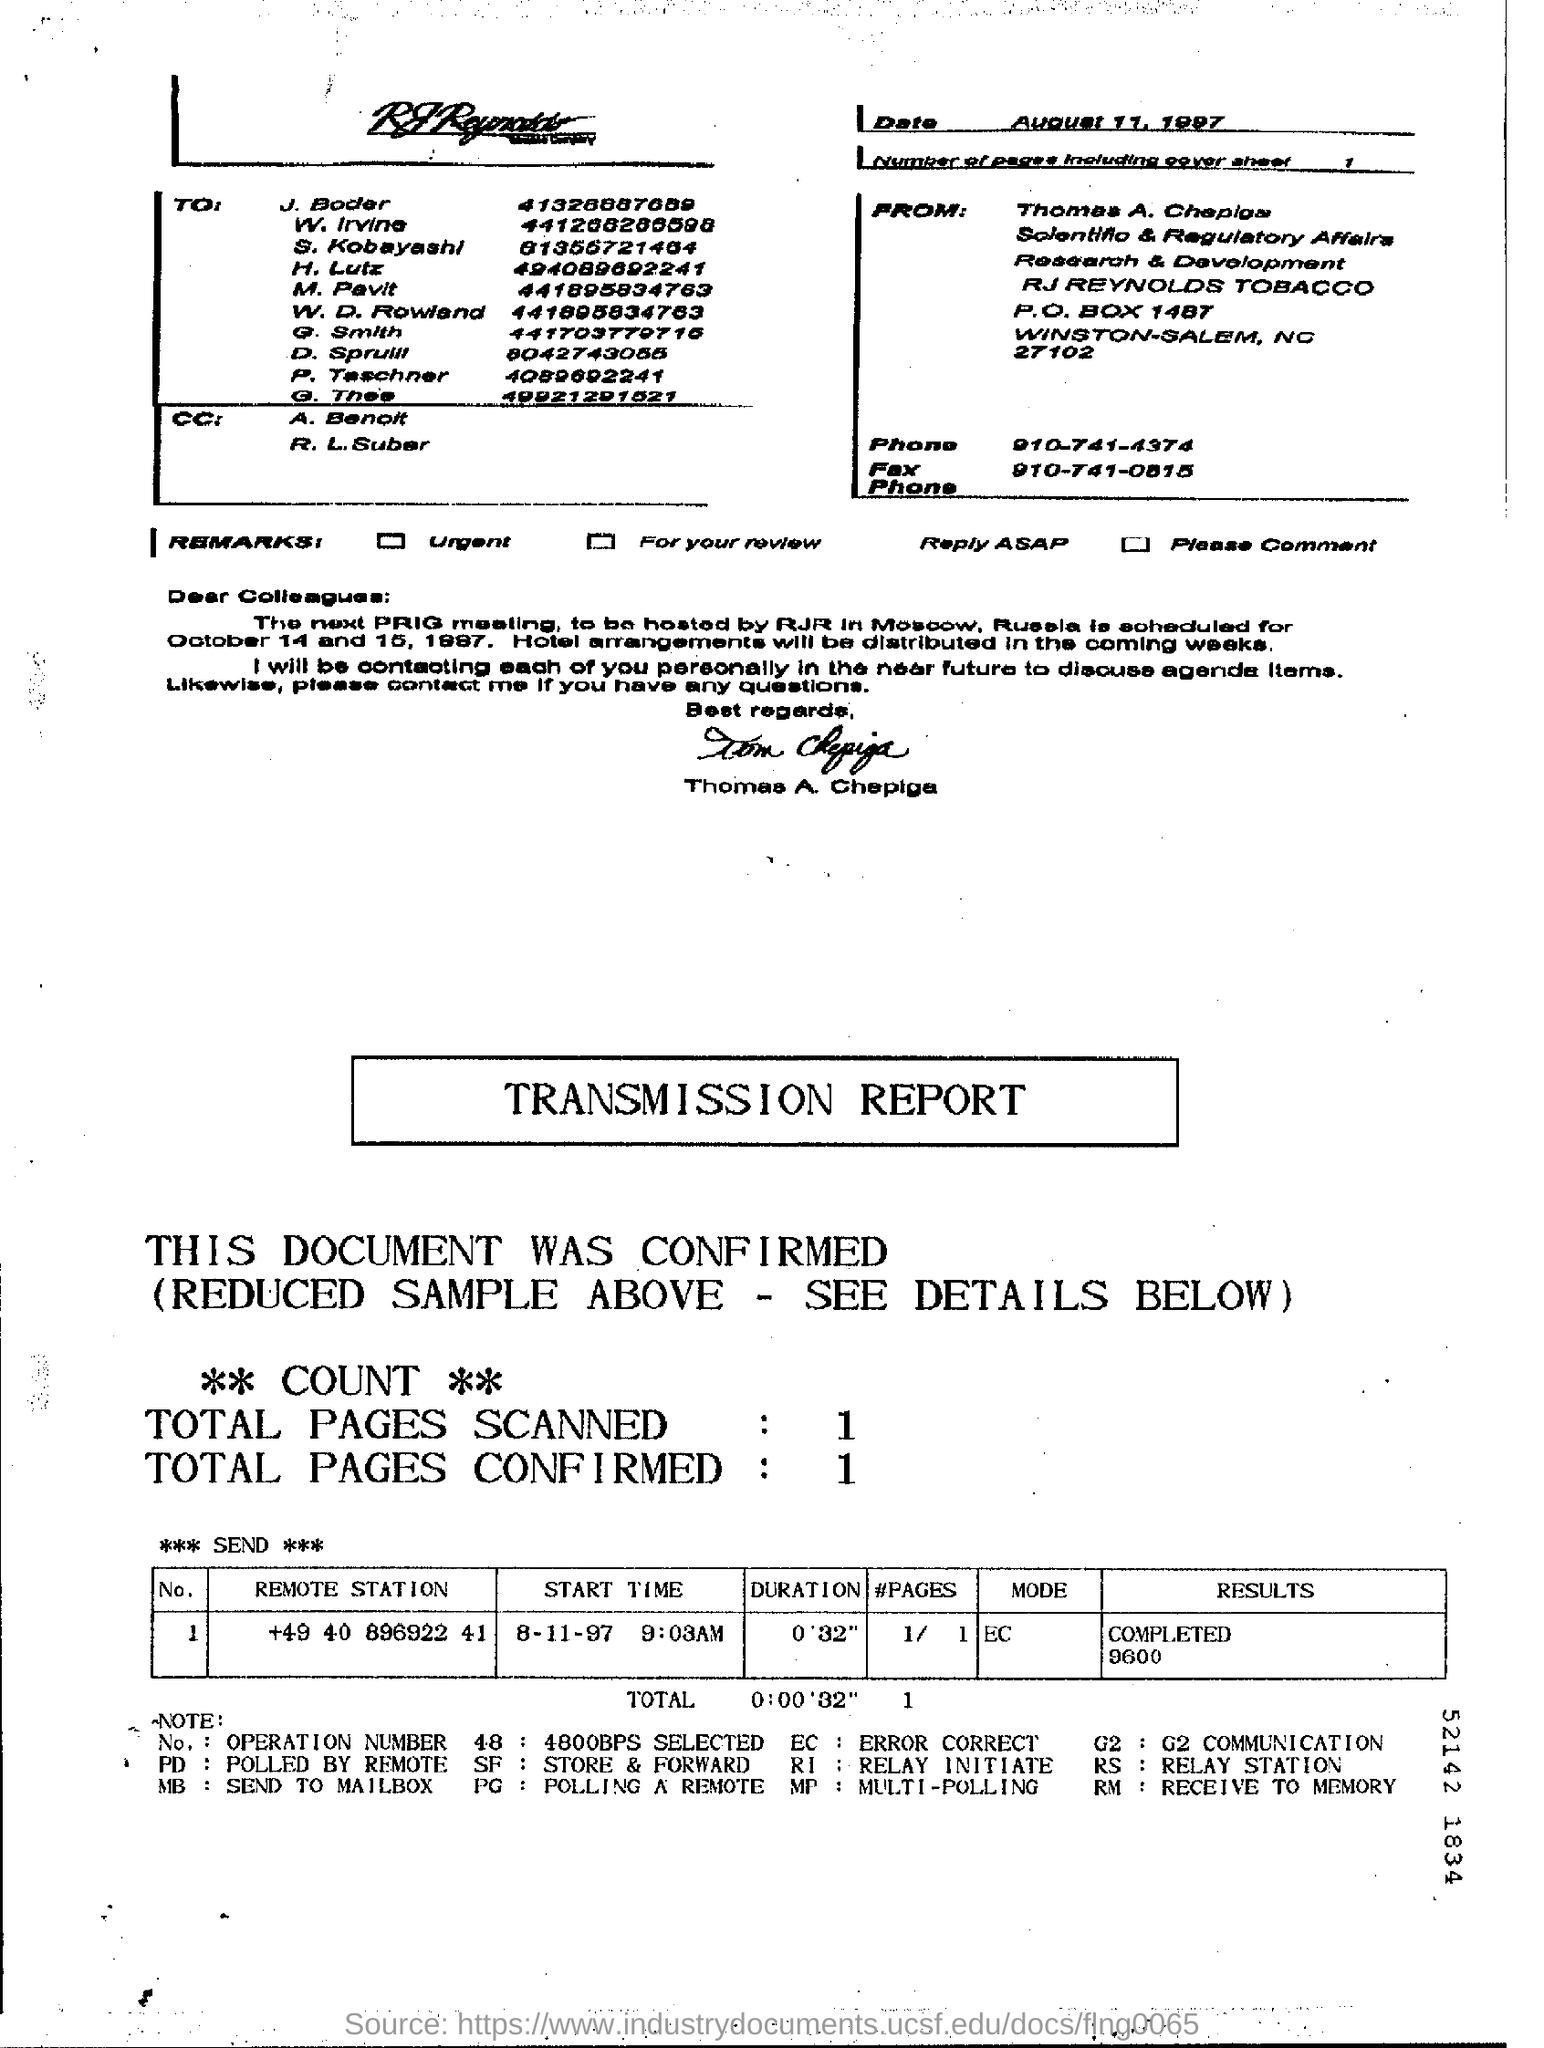Who is the sender of the FAX?
Your answer should be compact. Tom Chepiga. What is the Phone No of Thomas A. Chepiga?
Provide a succinct answer. 910-741-4374. What is the date mentioned in the fax sheet?
Your answer should be very brief. August 11, 1997. How many pages are there in the fax including cover sheet?
Offer a very short reply. 1. What is the mode given in the transmission report?
Provide a short and direct response. EC. 